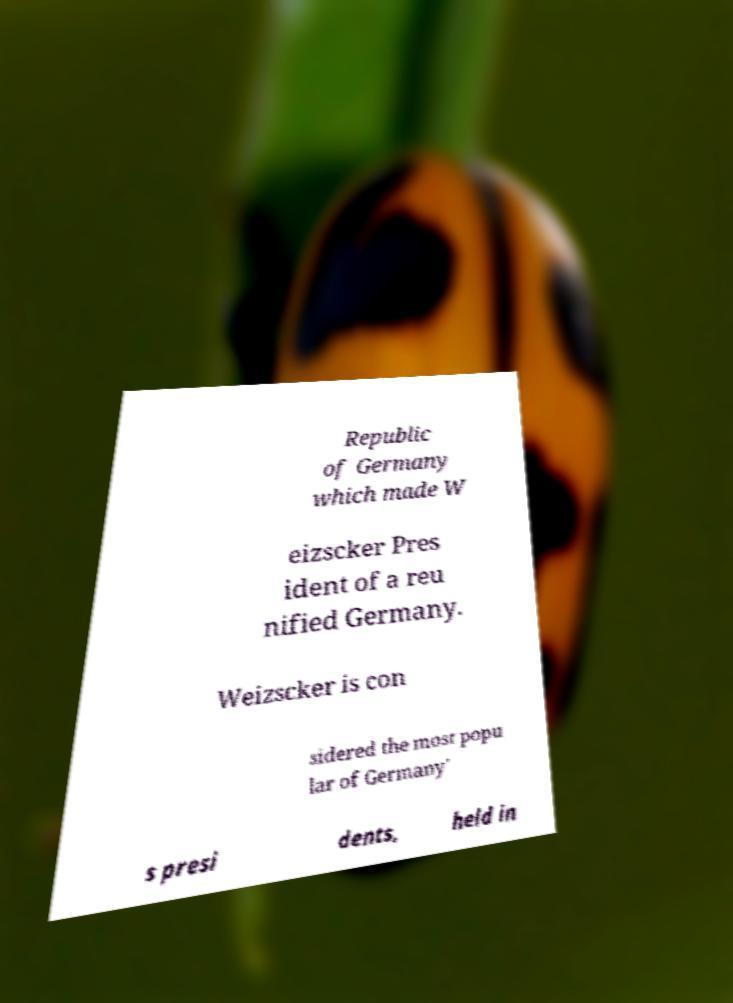Can you accurately transcribe the text from the provided image for me? Republic of Germany which made W eizscker Pres ident of a reu nified Germany. Weizscker is con sidered the most popu lar of Germany' s presi dents, held in 